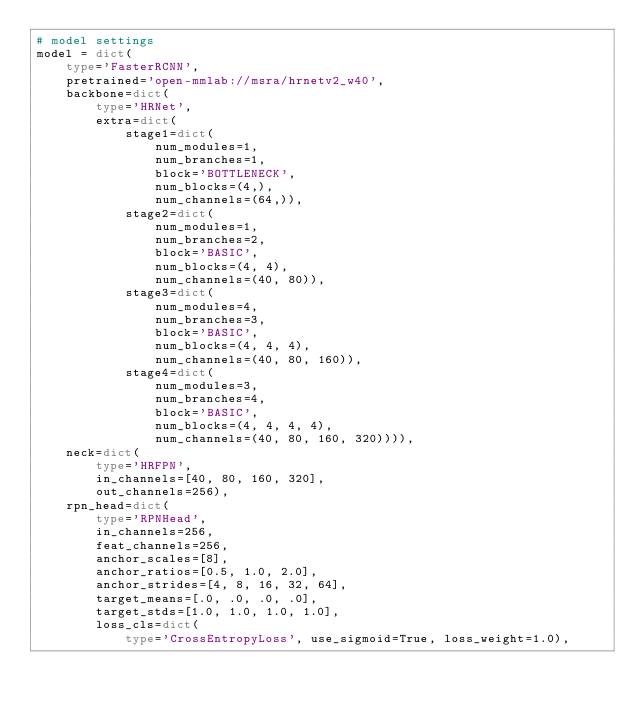<code> <loc_0><loc_0><loc_500><loc_500><_Python_># model settings
model = dict(
    type='FasterRCNN',
    pretrained='open-mmlab://msra/hrnetv2_w40',
    backbone=dict(
        type='HRNet',
        extra=dict(
            stage1=dict(
                num_modules=1,
                num_branches=1,
                block='BOTTLENECK',
                num_blocks=(4,),
                num_channels=(64,)),
            stage2=dict(
                num_modules=1,
                num_branches=2,
                block='BASIC',
                num_blocks=(4, 4),
                num_channels=(40, 80)),
            stage3=dict(
                num_modules=4,
                num_branches=3,
                block='BASIC',
                num_blocks=(4, 4, 4),
                num_channels=(40, 80, 160)),
            stage4=dict(
                num_modules=3,
                num_branches=4,
                block='BASIC',
                num_blocks=(4, 4, 4, 4),
                num_channels=(40, 80, 160, 320)))),
    neck=dict(
        type='HRFPN',
        in_channels=[40, 80, 160, 320],
        out_channels=256),
    rpn_head=dict(
        type='RPNHead',
        in_channels=256,
        feat_channels=256,
        anchor_scales=[8],
        anchor_ratios=[0.5, 1.0, 2.0],
        anchor_strides=[4, 8, 16, 32, 64],
        target_means=[.0, .0, .0, .0],
        target_stds=[1.0, 1.0, 1.0, 1.0],
        loss_cls=dict(
            type='CrossEntropyLoss', use_sigmoid=True, loss_weight=1.0),</code> 